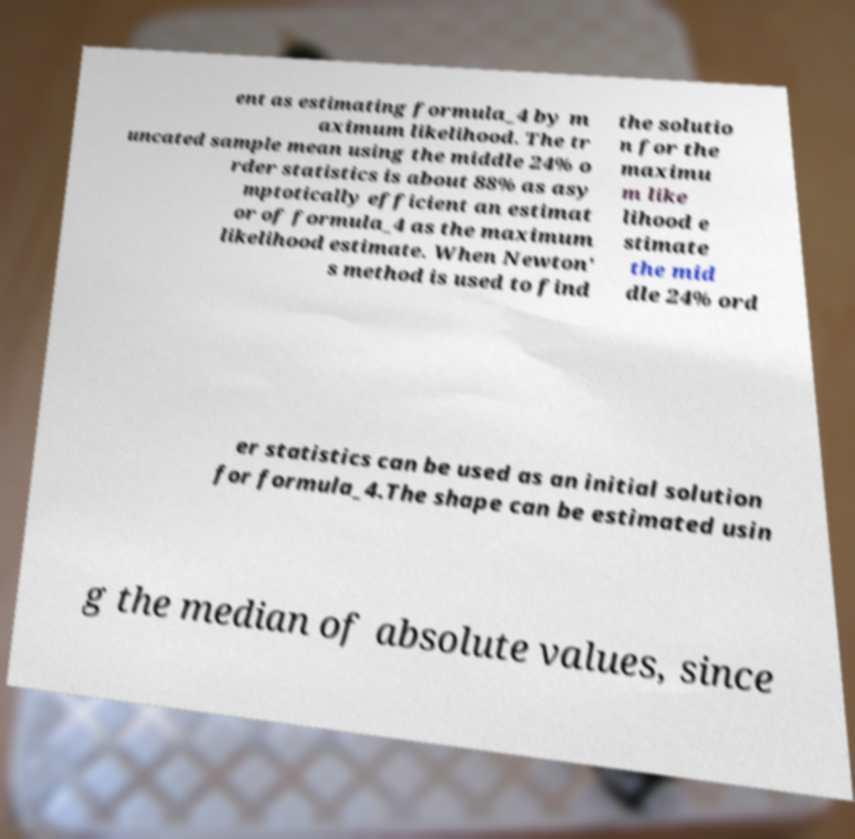Please identify and transcribe the text found in this image. ent as estimating formula_4 by m aximum likelihood. The tr uncated sample mean using the middle 24% o rder statistics is about 88% as asy mptotically efficient an estimat or of formula_4 as the maximum likelihood estimate. When Newton' s method is used to find the solutio n for the maximu m like lihood e stimate the mid dle 24% ord er statistics can be used as an initial solution for formula_4.The shape can be estimated usin g the median of absolute values, since 